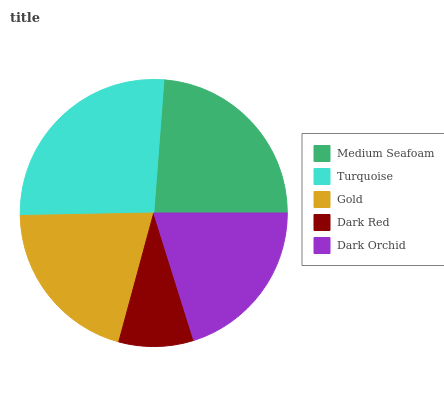Is Dark Red the minimum?
Answer yes or no. Yes. Is Turquoise the maximum?
Answer yes or no. Yes. Is Gold the minimum?
Answer yes or no. No. Is Gold the maximum?
Answer yes or no. No. Is Turquoise greater than Gold?
Answer yes or no. Yes. Is Gold less than Turquoise?
Answer yes or no. Yes. Is Gold greater than Turquoise?
Answer yes or no. No. Is Turquoise less than Gold?
Answer yes or no. No. Is Gold the high median?
Answer yes or no. Yes. Is Gold the low median?
Answer yes or no. Yes. Is Dark Red the high median?
Answer yes or no. No. Is Medium Seafoam the low median?
Answer yes or no. No. 